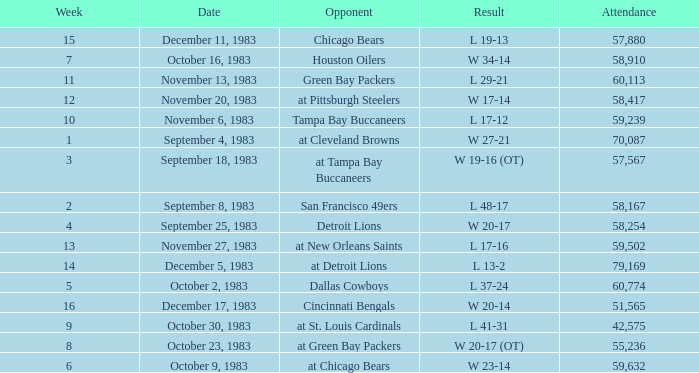What happened on November 20, 1983 before week 15? W 17-14. 